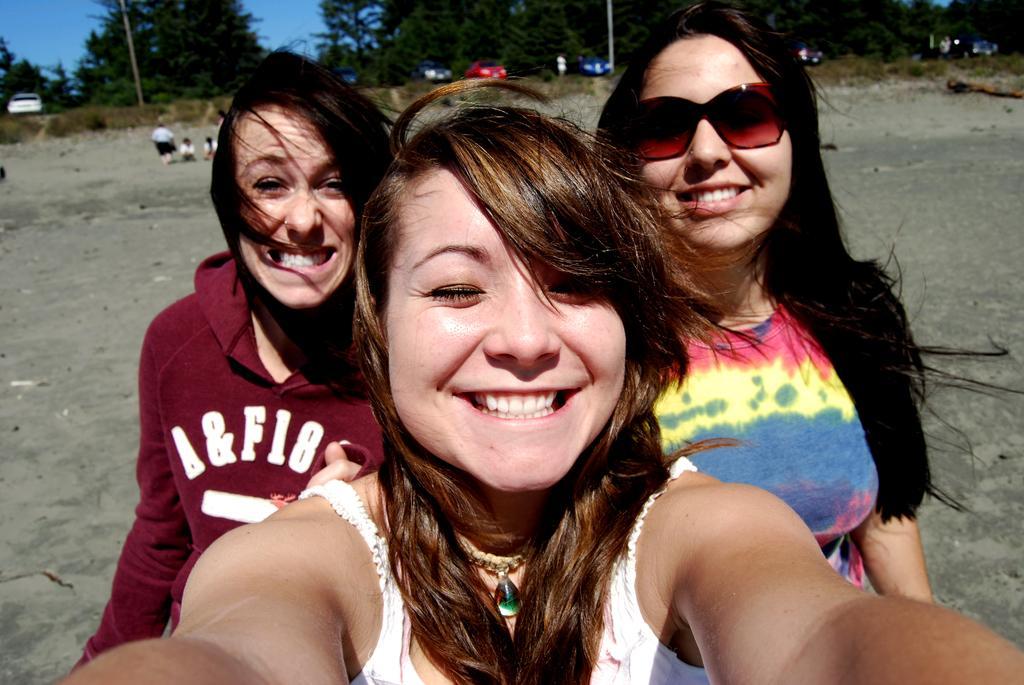How would you summarize this image in a sentence or two? In this picture I can see 3 women who are smiling and standing in front this image. In the background I see the trees and few cars and in the middle of the picture I see the ground and I see few people. 